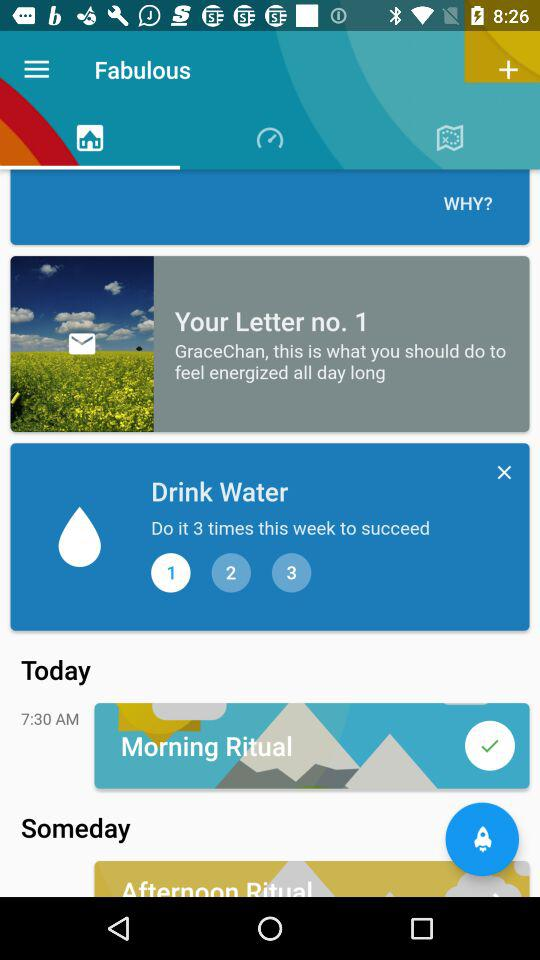How many times does the user need to drink water this week to succeed?
Answer the question using a single word or phrase. 3 